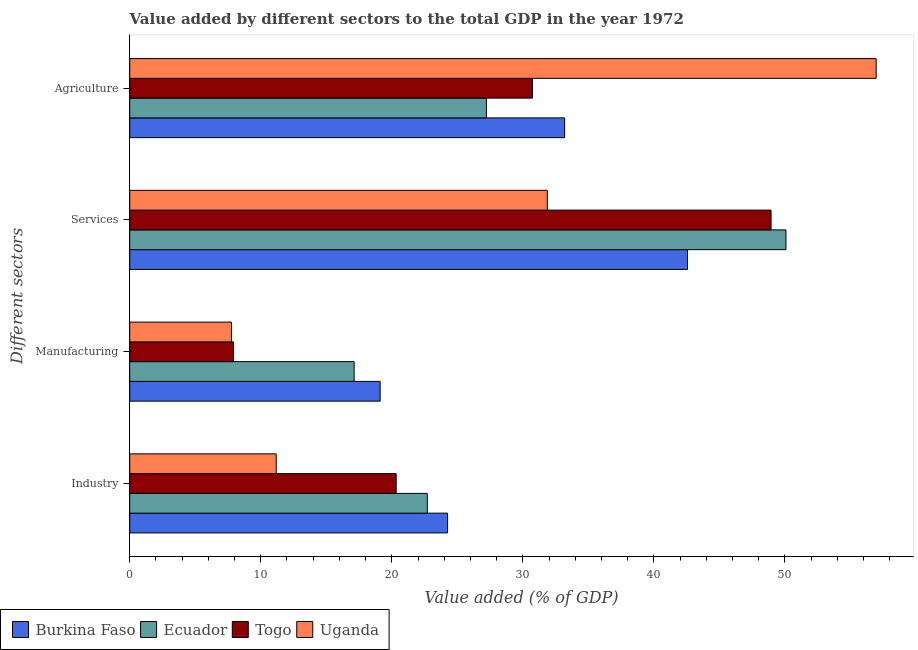How many different coloured bars are there?
Your response must be concise. 4. Are the number of bars per tick equal to the number of legend labels?
Your answer should be very brief. Yes. Are the number of bars on each tick of the Y-axis equal?
Ensure brevity in your answer.  Yes. How many bars are there on the 4th tick from the top?
Provide a short and direct response. 4. What is the label of the 3rd group of bars from the top?
Ensure brevity in your answer.  Manufacturing. What is the value added by services sector in Uganda?
Your answer should be compact. 31.86. Across all countries, what is the maximum value added by manufacturing sector?
Offer a terse response. 19.11. Across all countries, what is the minimum value added by industrial sector?
Your response must be concise. 11.18. In which country was the value added by services sector maximum?
Offer a very short reply. Ecuador. In which country was the value added by manufacturing sector minimum?
Provide a short and direct response. Uganda. What is the total value added by industrial sector in the graph?
Provide a short and direct response. 78.47. What is the difference between the value added by services sector in Burkina Faso and that in Togo?
Provide a succinct answer. -6.37. What is the difference between the value added by agricultural sector in Burkina Faso and the value added by manufacturing sector in Togo?
Provide a succinct answer. 25.27. What is the average value added by industrial sector per country?
Provide a short and direct response. 19.62. What is the difference between the value added by agricultural sector and value added by services sector in Togo?
Make the answer very short. -18.2. In how many countries, is the value added by manufacturing sector greater than 44 %?
Your answer should be compact. 0. What is the ratio of the value added by industrial sector in Uganda to that in Burkina Faso?
Your response must be concise. 0.46. Is the difference between the value added by industrial sector in Uganda and Ecuador greater than the difference between the value added by agricultural sector in Uganda and Ecuador?
Provide a succinct answer. No. What is the difference between the highest and the second highest value added by services sector?
Provide a succinct answer. 1.14. What is the difference between the highest and the lowest value added by industrial sector?
Keep it short and to the point. 13.07. In how many countries, is the value added by industrial sector greater than the average value added by industrial sector taken over all countries?
Offer a very short reply. 3. Is the sum of the value added by manufacturing sector in Uganda and Ecuador greater than the maximum value added by industrial sector across all countries?
Provide a short and direct response. Yes. What does the 3rd bar from the top in Industry represents?
Provide a short and direct response. Ecuador. What does the 1st bar from the bottom in Manufacturing represents?
Offer a terse response. Burkina Faso. Is it the case that in every country, the sum of the value added by industrial sector and value added by manufacturing sector is greater than the value added by services sector?
Provide a succinct answer. No. Does the graph contain grids?
Your answer should be very brief. No. Where does the legend appear in the graph?
Ensure brevity in your answer.  Bottom left. What is the title of the graph?
Give a very brief answer. Value added by different sectors to the total GDP in the year 1972. Does "Isle of Man" appear as one of the legend labels in the graph?
Make the answer very short. No. What is the label or title of the X-axis?
Provide a succinct answer. Value added (% of GDP). What is the label or title of the Y-axis?
Your response must be concise. Different sectors. What is the Value added (% of GDP) of Burkina Faso in Industry?
Offer a terse response. 24.25. What is the Value added (% of GDP) of Ecuador in Industry?
Provide a succinct answer. 22.71. What is the Value added (% of GDP) of Togo in Industry?
Offer a very short reply. 20.33. What is the Value added (% of GDP) of Uganda in Industry?
Give a very brief answer. 11.18. What is the Value added (% of GDP) of Burkina Faso in Manufacturing?
Your answer should be very brief. 19.11. What is the Value added (% of GDP) of Ecuador in Manufacturing?
Your answer should be compact. 17.12. What is the Value added (% of GDP) in Togo in Manufacturing?
Your answer should be very brief. 7.92. What is the Value added (% of GDP) of Uganda in Manufacturing?
Give a very brief answer. 7.76. What is the Value added (% of GDP) of Burkina Faso in Services?
Make the answer very short. 42.56. What is the Value added (% of GDP) of Ecuador in Services?
Your answer should be very brief. 50.07. What is the Value added (% of GDP) of Togo in Services?
Offer a very short reply. 48.94. What is the Value added (% of GDP) of Uganda in Services?
Your response must be concise. 31.86. What is the Value added (% of GDP) of Burkina Faso in Agriculture?
Offer a terse response. 33.19. What is the Value added (% of GDP) in Ecuador in Agriculture?
Give a very brief answer. 27.22. What is the Value added (% of GDP) in Togo in Agriculture?
Offer a terse response. 30.73. What is the Value added (% of GDP) of Uganda in Agriculture?
Give a very brief answer. 56.96. Across all Different sectors, what is the maximum Value added (% of GDP) in Burkina Faso?
Provide a succinct answer. 42.56. Across all Different sectors, what is the maximum Value added (% of GDP) in Ecuador?
Give a very brief answer. 50.07. Across all Different sectors, what is the maximum Value added (% of GDP) of Togo?
Ensure brevity in your answer.  48.94. Across all Different sectors, what is the maximum Value added (% of GDP) in Uganda?
Offer a terse response. 56.96. Across all Different sectors, what is the minimum Value added (% of GDP) of Burkina Faso?
Your response must be concise. 19.11. Across all Different sectors, what is the minimum Value added (% of GDP) of Ecuador?
Keep it short and to the point. 17.12. Across all Different sectors, what is the minimum Value added (% of GDP) in Togo?
Provide a short and direct response. 7.92. Across all Different sectors, what is the minimum Value added (% of GDP) of Uganda?
Your answer should be very brief. 7.76. What is the total Value added (% of GDP) of Burkina Faso in the graph?
Provide a succinct answer. 119.11. What is the total Value added (% of GDP) of Ecuador in the graph?
Offer a very short reply. 117.12. What is the total Value added (% of GDP) in Togo in the graph?
Your answer should be very brief. 107.92. What is the total Value added (% of GDP) of Uganda in the graph?
Provide a short and direct response. 107.76. What is the difference between the Value added (% of GDP) in Burkina Faso in Industry and that in Manufacturing?
Provide a short and direct response. 5.14. What is the difference between the Value added (% of GDP) of Ecuador in Industry and that in Manufacturing?
Make the answer very short. 5.58. What is the difference between the Value added (% of GDP) in Togo in Industry and that in Manufacturing?
Ensure brevity in your answer.  12.41. What is the difference between the Value added (% of GDP) in Uganda in Industry and that in Manufacturing?
Ensure brevity in your answer.  3.42. What is the difference between the Value added (% of GDP) of Burkina Faso in Industry and that in Services?
Keep it short and to the point. -18.31. What is the difference between the Value added (% of GDP) of Ecuador in Industry and that in Services?
Your answer should be compact. -27.37. What is the difference between the Value added (% of GDP) in Togo in Industry and that in Services?
Make the answer very short. -28.61. What is the difference between the Value added (% of GDP) of Uganda in Industry and that in Services?
Provide a succinct answer. -20.69. What is the difference between the Value added (% of GDP) in Burkina Faso in Industry and that in Agriculture?
Offer a very short reply. -8.93. What is the difference between the Value added (% of GDP) of Ecuador in Industry and that in Agriculture?
Offer a very short reply. -4.51. What is the difference between the Value added (% of GDP) of Togo in Industry and that in Agriculture?
Your response must be concise. -10.4. What is the difference between the Value added (% of GDP) in Uganda in Industry and that in Agriculture?
Provide a succinct answer. -45.78. What is the difference between the Value added (% of GDP) in Burkina Faso in Manufacturing and that in Services?
Your answer should be very brief. -23.45. What is the difference between the Value added (% of GDP) in Ecuador in Manufacturing and that in Services?
Offer a terse response. -32.95. What is the difference between the Value added (% of GDP) of Togo in Manufacturing and that in Services?
Keep it short and to the point. -41.02. What is the difference between the Value added (% of GDP) of Uganda in Manufacturing and that in Services?
Make the answer very short. -24.1. What is the difference between the Value added (% of GDP) in Burkina Faso in Manufacturing and that in Agriculture?
Provide a short and direct response. -14.08. What is the difference between the Value added (% of GDP) in Ecuador in Manufacturing and that in Agriculture?
Give a very brief answer. -10.09. What is the difference between the Value added (% of GDP) of Togo in Manufacturing and that in Agriculture?
Your answer should be very brief. -22.81. What is the difference between the Value added (% of GDP) in Uganda in Manufacturing and that in Agriculture?
Offer a terse response. -49.2. What is the difference between the Value added (% of GDP) of Burkina Faso in Services and that in Agriculture?
Your answer should be very brief. 9.38. What is the difference between the Value added (% of GDP) in Ecuador in Services and that in Agriculture?
Ensure brevity in your answer.  22.86. What is the difference between the Value added (% of GDP) of Togo in Services and that in Agriculture?
Offer a very short reply. 18.2. What is the difference between the Value added (% of GDP) of Uganda in Services and that in Agriculture?
Ensure brevity in your answer.  -25.09. What is the difference between the Value added (% of GDP) of Burkina Faso in Industry and the Value added (% of GDP) of Ecuador in Manufacturing?
Give a very brief answer. 7.13. What is the difference between the Value added (% of GDP) of Burkina Faso in Industry and the Value added (% of GDP) of Togo in Manufacturing?
Your answer should be compact. 16.33. What is the difference between the Value added (% of GDP) of Burkina Faso in Industry and the Value added (% of GDP) of Uganda in Manufacturing?
Make the answer very short. 16.49. What is the difference between the Value added (% of GDP) of Ecuador in Industry and the Value added (% of GDP) of Togo in Manufacturing?
Offer a terse response. 14.79. What is the difference between the Value added (% of GDP) of Ecuador in Industry and the Value added (% of GDP) of Uganda in Manufacturing?
Give a very brief answer. 14.94. What is the difference between the Value added (% of GDP) of Togo in Industry and the Value added (% of GDP) of Uganda in Manufacturing?
Your answer should be very brief. 12.57. What is the difference between the Value added (% of GDP) of Burkina Faso in Industry and the Value added (% of GDP) of Ecuador in Services?
Make the answer very short. -25.82. What is the difference between the Value added (% of GDP) in Burkina Faso in Industry and the Value added (% of GDP) in Togo in Services?
Your answer should be compact. -24.68. What is the difference between the Value added (% of GDP) in Burkina Faso in Industry and the Value added (% of GDP) in Uganda in Services?
Your response must be concise. -7.61. What is the difference between the Value added (% of GDP) of Ecuador in Industry and the Value added (% of GDP) of Togo in Services?
Provide a succinct answer. -26.23. What is the difference between the Value added (% of GDP) in Ecuador in Industry and the Value added (% of GDP) in Uganda in Services?
Your answer should be very brief. -9.16. What is the difference between the Value added (% of GDP) in Togo in Industry and the Value added (% of GDP) in Uganda in Services?
Your response must be concise. -11.53. What is the difference between the Value added (% of GDP) of Burkina Faso in Industry and the Value added (% of GDP) of Ecuador in Agriculture?
Give a very brief answer. -2.97. What is the difference between the Value added (% of GDP) of Burkina Faso in Industry and the Value added (% of GDP) of Togo in Agriculture?
Ensure brevity in your answer.  -6.48. What is the difference between the Value added (% of GDP) in Burkina Faso in Industry and the Value added (% of GDP) in Uganda in Agriculture?
Your response must be concise. -32.71. What is the difference between the Value added (% of GDP) of Ecuador in Industry and the Value added (% of GDP) of Togo in Agriculture?
Give a very brief answer. -8.03. What is the difference between the Value added (% of GDP) in Ecuador in Industry and the Value added (% of GDP) in Uganda in Agriculture?
Make the answer very short. -34.25. What is the difference between the Value added (% of GDP) in Togo in Industry and the Value added (% of GDP) in Uganda in Agriculture?
Provide a succinct answer. -36.63. What is the difference between the Value added (% of GDP) in Burkina Faso in Manufacturing and the Value added (% of GDP) in Ecuador in Services?
Provide a short and direct response. -30.97. What is the difference between the Value added (% of GDP) of Burkina Faso in Manufacturing and the Value added (% of GDP) of Togo in Services?
Offer a very short reply. -29.83. What is the difference between the Value added (% of GDP) in Burkina Faso in Manufacturing and the Value added (% of GDP) in Uganda in Services?
Give a very brief answer. -12.76. What is the difference between the Value added (% of GDP) of Ecuador in Manufacturing and the Value added (% of GDP) of Togo in Services?
Your response must be concise. -31.81. What is the difference between the Value added (% of GDP) in Ecuador in Manufacturing and the Value added (% of GDP) in Uganda in Services?
Offer a terse response. -14.74. What is the difference between the Value added (% of GDP) of Togo in Manufacturing and the Value added (% of GDP) of Uganda in Services?
Your answer should be compact. -23.95. What is the difference between the Value added (% of GDP) of Burkina Faso in Manufacturing and the Value added (% of GDP) of Ecuador in Agriculture?
Your answer should be compact. -8.11. What is the difference between the Value added (% of GDP) of Burkina Faso in Manufacturing and the Value added (% of GDP) of Togo in Agriculture?
Your response must be concise. -11.62. What is the difference between the Value added (% of GDP) in Burkina Faso in Manufacturing and the Value added (% of GDP) in Uganda in Agriculture?
Make the answer very short. -37.85. What is the difference between the Value added (% of GDP) of Ecuador in Manufacturing and the Value added (% of GDP) of Togo in Agriculture?
Offer a very short reply. -13.61. What is the difference between the Value added (% of GDP) in Ecuador in Manufacturing and the Value added (% of GDP) in Uganda in Agriculture?
Give a very brief answer. -39.83. What is the difference between the Value added (% of GDP) of Togo in Manufacturing and the Value added (% of GDP) of Uganda in Agriculture?
Your response must be concise. -49.04. What is the difference between the Value added (% of GDP) of Burkina Faso in Services and the Value added (% of GDP) of Ecuador in Agriculture?
Give a very brief answer. 15.34. What is the difference between the Value added (% of GDP) of Burkina Faso in Services and the Value added (% of GDP) of Togo in Agriculture?
Keep it short and to the point. 11.83. What is the difference between the Value added (% of GDP) of Burkina Faso in Services and the Value added (% of GDP) of Uganda in Agriculture?
Ensure brevity in your answer.  -14.4. What is the difference between the Value added (% of GDP) of Ecuador in Services and the Value added (% of GDP) of Togo in Agriculture?
Offer a very short reply. 19.34. What is the difference between the Value added (% of GDP) of Ecuador in Services and the Value added (% of GDP) of Uganda in Agriculture?
Your response must be concise. -6.88. What is the difference between the Value added (% of GDP) of Togo in Services and the Value added (% of GDP) of Uganda in Agriculture?
Your response must be concise. -8.02. What is the average Value added (% of GDP) in Burkina Faso per Different sectors?
Offer a terse response. 29.78. What is the average Value added (% of GDP) of Ecuador per Different sectors?
Provide a short and direct response. 29.28. What is the average Value added (% of GDP) in Togo per Different sectors?
Keep it short and to the point. 26.98. What is the average Value added (% of GDP) in Uganda per Different sectors?
Provide a short and direct response. 26.94. What is the difference between the Value added (% of GDP) in Burkina Faso and Value added (% of GDP) in Ecuador in Industry?
Ensure brevity in your answer.  1.55. What is the difference between the Value added (% of GDP) of Burkina Faso and Value added (% of GDP) of Togo in Industry?
Offer a very short reply. 3.92. What is the difference between the Value added (% of GDP) of Burkina Faso and Value added (% of GDP) of Uganda in Industry?
Give a very brief answer. 13.07. What is the difference between the Value added (% of GDP) of Ecuador and Value added (% of GDP) of Togo in Industry?
Your response must be concise. 2.38. What is the difference between the Value added (% of GDP) in Ecuador and Value added (% of GDP) in Uganda in Industry?
Your response must be concise. 11.53. What is the difference between the Value added (% of GDP) in Togo and Value added (% of GDP) in Uganda in Industry?
Your response must be concise. 9.15. What is the difference between the Value added (% of GDP) in Burkina Faso and Value added (% of GDP) in Ecuador in Manufacturing?
Ensure brevity in your answer.  1.98. What is the difference between the Value added (% of GDP) in Burkina Faso and Value added (% of GDP) in Togo in Manufacturing?
Make the answer very short. 11.19. What is the difference between the Value added (% of GDP) in Burkina Faso and Value added (% of GDP) in Uganda in Manufacturing?
Keep it short and to the point. 11.35. What is the difference between the Value added (% of GDP) of Ecuador and Value added (% of GDP) of Togo in Manufacturing?
Your answer should be compact. 9.2. What is the difference between the Value added (% of GDP) in Ecuador and Value added (% of GDP) in Uganda in Manufacturing?
Give a very brief answer. 9.36. What is the difference between the Value added (% of GDP) of Togo and Value added (% of GDP) of Uganda in Manufacturing?
Your answer should be compact. 0.16. What is the difference between the Value added (% of GDP) of Burkina Faso and Value added (% of GDP) of Ecuador in Services?
Make the answer very short. -7.51. What is the difference between the Value added (% of GDP) in Burkina Faso and Value added (% of GDP) in Togo in Services?
Offer a very short reply. -6.37. What is the difference between the Value added (% of GDP) in Burkina Faso and Value added (% of GDP) in Uganda in Services?
Ensure brevity in your answer.  10.7. What is the difference between the Value added (% of GDP) of Ecuador and Value added (% of GDP) of Togo in Services?
Your response must be concise. 1.14. What is the difference between the Value added (% of GDP) in Ecuador and Value added (% of GDP) in Uganda in Services?
Your answer should be compact. 18.21. What is the difference between the Value added (% of GDP) in Togo and Value added (% of GDP) in Uganda in Services?
Give a very brief answer. 17.07. What is the difference between the Value added (% of GDP) of Burkina Faso and Value added (% of GDP) of Ecuador in Agriculture?
Offer a terse response. 5.97. What is the difference between the Value added (% of GDP) of Burkina Faso and Value added (% of GDP) of Togo in Agriculture?
Keep it short and to the point. 2.45. What is the difference between the Value added (% of GDP) of Burkina Faso and Value added (% of GDP) of Uganda in Agriculture?
Your response must be concise. -23.77. What is the difference between the Value added (% of GDP) in Ecuador and Value added (% of GDP) in Togo in Agriculture?
Give a very brief answer. -3.51. What is the difference between the Value added (% of GDP) of Ecuador and Value added (% of GDP) of Uganda in Agriculture?
Your response must be concise. -29.74. What is the difference between the Value added (% of GDP) in Togo and Value added (% of GDP) in Uganda in Agriculture?
Your answer should be compact. -26.23. What is the ratio of the Value added (% of GDP) in Burkina Faso in Industry to that in Manufacturing?
Keep it short and to the point. 1.27. What is the ratio of the Value added (% of GDP) in Ecuador in Industry to that in Manufacturing?
Offer a very short reply. 1.33. What is the ratio of the Value added (% of GDP) of Togo in Industry to that in Manufacturing?
Ensure brevity in your answer.  2.57. What is the ratio of the Value added (% of GDP) of Uganda in Industry to that in Manufacturing?
Ensure brevity in your answer.  1.44. What is the ratio of the Value added (% of GDP) in Burkina Faso in Industry to that in Services?
Keep it short and to the point. 0.57. What is the ratio of the Value added (% of GDP) of Ecuador in Industry to that in Services?
Your response must be concise. 0.45. What is the ratio of the Value added (% of GDP) in Togo in Industry to that in Services?
Offer a very short reply. 0.42. What is the ratio of the Value added (% of GDP) of Uganda in Industry to that in Services?
Provide a short and direct response. 0.35. What is the ratio of the Value added (% of GDP) in Burkina Faso in Industry to that in Agriculture?
Keep it short and to the point. 0.73. What is the ratio of the Value added (% of GDP) of Ecuador in Industry to that in Agriculture?
Give a very brief answer. 0.83. What is the ratio of the Value added (% of GDP) in Togo in Industry to that in Agriculture?
Offer a very short reply. 0.66. What is the ratio of the Value added (% of GDP) of Uganda in Industry to that in Agriculture?
Offer a terse response. 0.2. What is the ratio of the Value added (% of GDP) in Burkina Faso in Manufacturing to that in Services?
Your answer should be very brief. 0.45. What is the ratio of the Value added (% of GDP) of Ecuador in Manufacturing to that in Services?
Offer a very short reply. 0.34. What is the ratio of the Value added (% of GDP) of Togo in Manufacturing to that in Services?
Make the answer very short. 0.16. What is the ratio of the Value added (% of GDP) in Uganda in Manufacturing to that in Services?
Make the answer very short. 0.24. What is the ratio of the Value added (% of GDP) in Burkina Faso in Manufacturing to that in Agriculture?
Your response must be concise. 0.58. What is the ratio of the Value added (% of GDP) in Ecuador in Manufacturing to that in Agriculture?
Your answer should be compact. 0.63. What is the ratio of the Value added (% of GDP) in Togo in Manufacturing to that in Agriculture?
Make the answer very short. 0.26. What is the ratio of the Value added (% of GDP) in Uganda in Manufacturing to that in Agriculture?
Ensure brevity in your answer.  0.14. What is the ratio of the Value added (% of GDP) in Burkina Faso in Services to that in Agriculture?
Offer a terse response. 1.28. What is the ratio of the Value added (% of GDP) of Ecuador in Services to that in Agriculture?
Ensure brevity in your answer.  1.84. What is the ratio of the Value added (% of GDP) in Togo in Services to that in Agriculture?
Your answer should be very brief. 1.59. What is the ratio of the Value added (% of GDP) in Uganda in Services to that in Agriculture?
Ensure brevity in your answer.  0.56. What is the difference between the highest and the second highest Value added (% of GDP) in Burkina Faso?
Provide a succinct answer. 9.38. What is the difference between the highest and the second highest Value added (% of GDP) of Ecuador?
Your answer should be compact. 22.86. What is the difference between the highest and the second highest Value added (% of GDP) of Togo?
Your answer should be compact. 18.2. What is the difference between the highest and the second highest Value added (% of GDP) of Uganda?
Provide a succinct answer. 25.09. What is the difference between the highest and the lowest Value added (% of GDP) of Burkina Faso?
Your answer should be compact. 23.45. What is the difference between the highest and the lowest Value added (% of GDP) in Ecuador?
Keep it short and to the point. 32.95. What is the difference between the highest and the lowest Value added (% of GDP) of Togo?
Ensure brevity in your answer.  41.02. What is the difference between the highest and the lowest Value added (% of GDP) of Uganda?
Your answer should be compact. 49.2. 